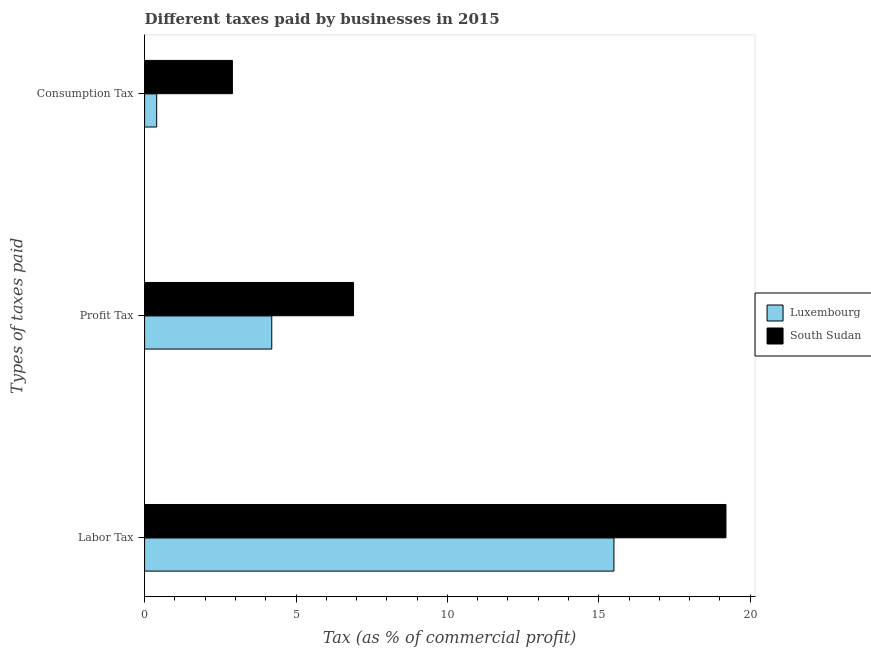How many different coloured bars are there?
Offer a very short reply. 2. Are the number of bars on each tick of the Y-axis equal?
Your answer should be very brief. Yes. How many bars are there on the 3rd tick from the top?
Give a very brief answer. 2. What is the label of the 3rd group of bars from the top?
Ensure brevity in your answer.  Labor Tax. Across all countries, what is the maximum percentage of consumption tax?
Provide a short and direct response. 2.9. Across all countries, what is the minimum percentage of consumption tax?
Your response must be concise. 0.4. In which country was the percentage of profit tax maximum?
Offer a very short reply. South Sudan. In which country was the percentage of consumption tax minimum?
Offer a very short reply. Luxembourg. What is the total percentage of profit tax in the graph?
Provide a short and direct response. 11.1. What is the difference between the percentage of labor tax in South Sudan and that in Luxembourg?
Your answer should be very brief. 3.7. What is the difference between the percentage of labor tax in South Sudan and the percentage of consumption tax in Luxembourg?
Give a very brief answer. 18.8. What is the average percentage of consumption tax per country?
Provide a succinct answer. 1.65. What is the difference between the percentage of profit tax and percentage of labor tax in Luxembourg?
Provide a short and direct response. -11.3. What is the ratio of the percentage of profit tax in Luxembourg to that in South Sudan?
Provide a succinct answer. 0.61. What is the difference between the highest and the second highest percentage of labor tax?
Provide a short and direct response. 3.7. What is the difference between the highest and the lowest percentage of consumption tax?
Your answer should be very brief. 2.5. In how many countries, is the percentage of consumption tax greater than the average percentage of consumption tax taken over all countries?
Make the answer very short. 1. Is the sum of the percentage of profit tax in South Sudan and Luxembourg greater than the maximum percentage of consumption tax across all countries?
Make the answer very short. Yes. What does the 2nd bar from the top in Profit Tax represents?
Keep it short and to the point. Luxembourg. What does the 1st bar from the bottom in Consumption Tax represents?
Offer a terse response. Luxembourg. Are all the bars in the graph horizontal?
Offer a terse response. Yes. Are the values on the major ticks of X-axis written in scientific E-notation?
Keep it short and to the point. No. Does the graph contain any zero values?
Provide a succinct answer. No. Does the graph contain grids?
Offer a very short reply. No. Where does the legend appear in the graph?
Provide a short and direct response. Center right. How are the legend labels stacked?
Provide a succinct answer. Vertical. What is the title of the graph?
Your answer should be compact. Different taxes paid by businesses in 2015. What is the label or title of the X-axis?
Provide a succinct answer. Tax (as % of commercial profit). What is the label or title of the Y-axis?
Provide a short and direct response. Types of taxes paid. What is the Tax (as % of commercial profit) in South Sudan in Labor Tax?
Offer a very short reply. 19.2. What is the Tax (as % of commercial profit) in South Sudan in Profit Tax?
Your response must be concise. 6.9. What is the Tax (as % of commercial profit) in Luxembourg in Consumption Tax?
Your response must be concise. 0.4. Across all Types of taxes paid, what is the maximum Tax (as % of commercial profit) of South Sudan?
Make the answer very short. 19.2. What is the total Tax (as % of commercial profit) of Luxembourg in the graph?
Provide a short and direct response. 20.1. What is the total Tax (as % of commercial profit) of South Sudan in the graph?
Your answer should be very brief. 29. What is the difference between the Tax (as % of commercial profit) in South Sudan in Labor Tax and that in Profit Tax?
Offer a very short reply. 12.3. What is the difference between the Tax (as % of commercial profit) of Luxembourg in Labor Tax and that in Consumption Tax?
Your answer should be very brief. 15.1. What is the difference between the Tax (as % of commercial profit) in South Sudan in Labor Tax and that in Consumption Tax?
Give a very brief answer. 16.3. What is the average Tax (as % of commercial profit) in South Sudan per Types of taxes paid?
Make the answer very short. 9.67. What is the difference between the Tax (as % of commercial profit) in Luxembourg and Tax (as % of commercial profit) in South Sudan in Profit Tax?
Your response must be concise. -2.7. What is the ratio of the Tax (as % of commercial profit) in Luxembourg in Labor Tax to that in Profit Tax?
Provide a short and direct response. 3.69. What is the ratio of the Tax (as % of commercial profit) of South Sudan in Labor Tax to that in Profit Tax?
Give a very brief answer. 2.78. What is the ratio of the Tax (as % of commercial profit) of Luxembourg in Labor Tax to that in Consumption Tax?
Offer a very short reply. 38.75. What is the ratio of the Tax (as % of commercial profit) of South Sudan in Labor Tax to that in Consumption Tax?
Offer a terse response. 6.62. What is the ratio of the Tax (as % of commercial profit) of South Sudan in Profit Tax to that in Consumption Tax?
Offer a terse response. 2.38. What is the difference between the highest and the second highest Tax (as % of commercial profit) in South Sudan?
Offer a terse response. 12.3. What is the difference between the highest and the lowest Tax (as % of commercial profit) of Luxembourg?
Your answer should be very brief. 15.1. 